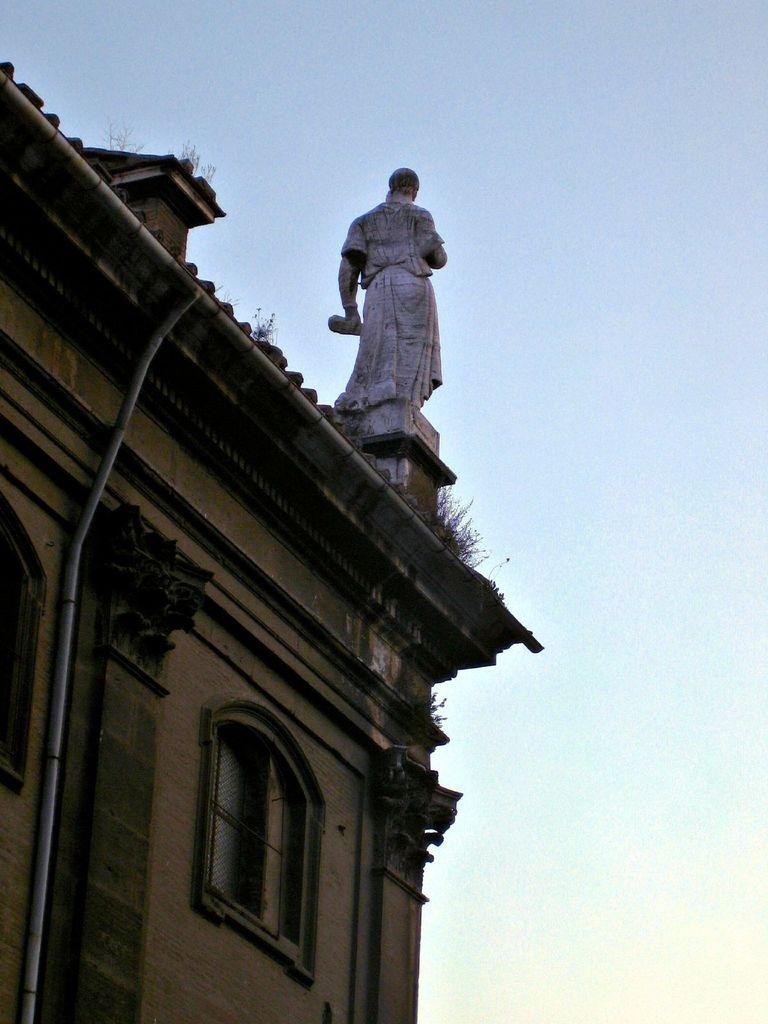What structure is located on the left side of the image? There is a building on the left side of the image. What is on top of the building? There is a statue on the building. What can be seen in the background of the image? There is a pipe and the sky visible in the background of the image. What type of soup is being served by the giants in the image? There are no giants or soup present in the image. What substance is being emitted from the pipe in the image? The image does not provide information about the substance being emitted from the pipe. 